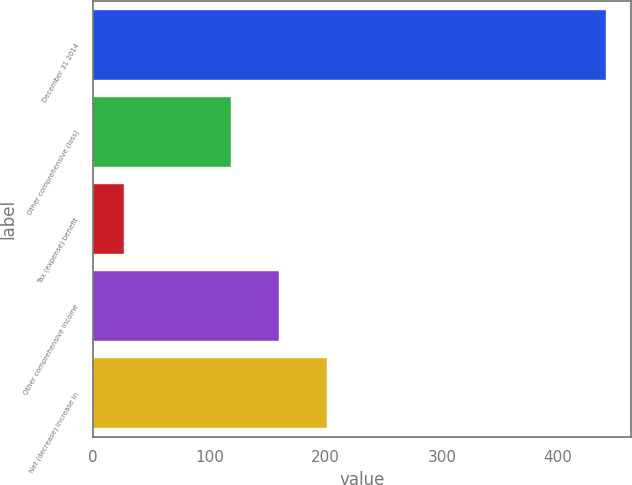<chart> <loc_0><loc_0><loc_500><loc_500><bar_chart><fcel>December 31 2014<fcel>Other comprehensive (loss)<fcel>Tax (expense) benefit<fcel>Other comprehensive income<fcel>Net (decrease) increase in<nl><fcel>441.1<fcel>118.3<fcel>26.1<fcel>159.8<fcel>201.3<nl></chart> 